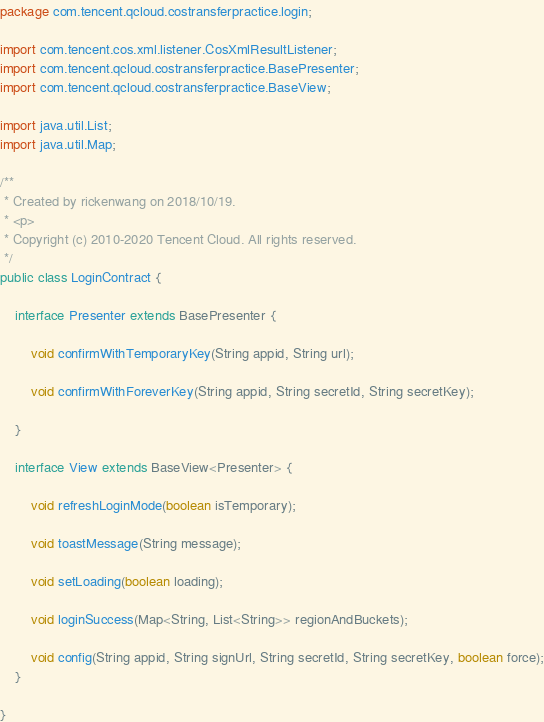<code> <loc_0><loc_0><loc_500><loc_500><_Java_>package com.tencent.qcloud.costransferpractice.login;

import com.tencent.cos.xml.listener.CosXmlResultListener;
import com.tencent.qcloud.costransferpractice.BasePresenter;
import com.tencent.qcloud.costransferpractice.BaseView;

import java.util.List;
import java.util.Map;

/**
 * Created by rickenwang on 2018/10/19.
 * <p>
 * Copyright (c) 2010-2020 Tencent Cloud. All rights reserved.
 */
public class LoginContract {

    interface Presenter extends BasePresenter {

        void confirmWithTemporaryKey(String appid, String url);

        void confirmWithForeverKey(String appid, String secretId, String secretKey);

    }

    interface View extends BaseView<Presenter> {

        void refreshLoginMode(boolean isTemporary);

        void toastMessage(String message);

        void setLoading(boolean loading);

        void loginSuccess(Map<String, List<String>> regionAndBuckets);

        void config(String appid, String signUrl, String secretId, String secretKey, boolean force);
    }

}
</code> 